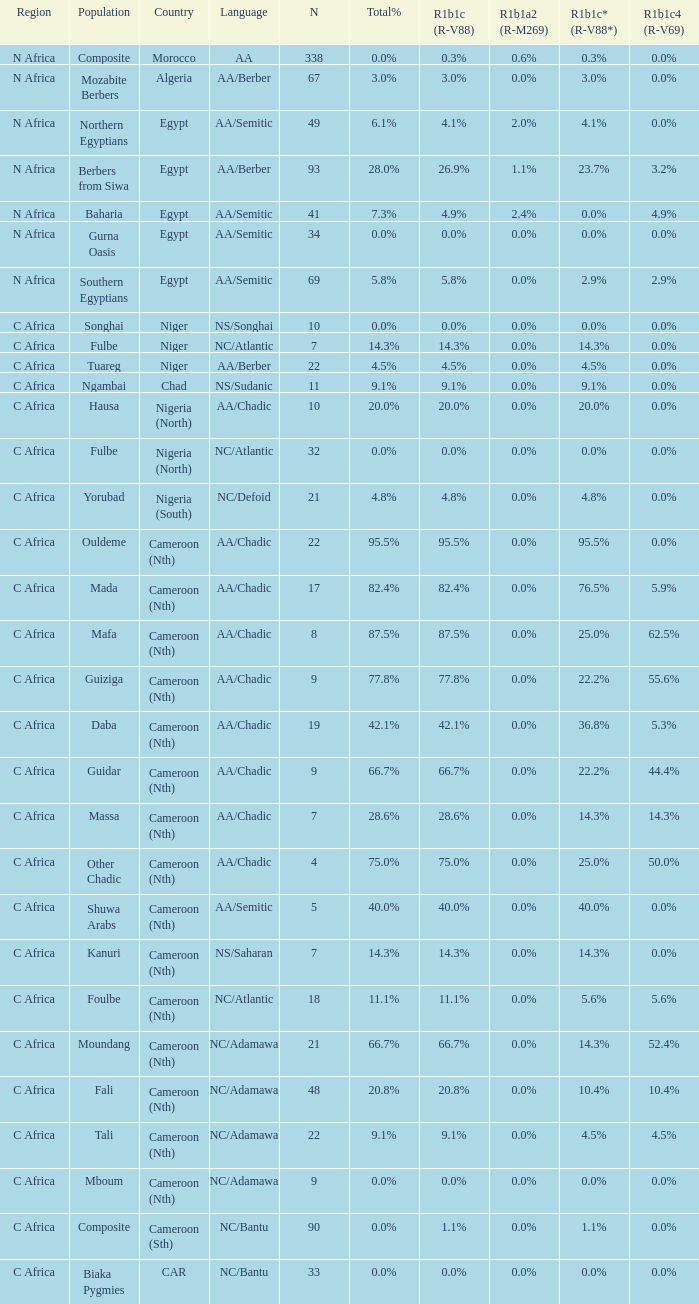What percentage is listed in column r1b1c (r-v88) for the 4.5% total percentage? 4.5%. 